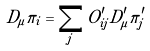<formula> <loc_0><loc_0><loc_500><loc_500>D _ { \mu } \pi _ { i } = \sum _ { j } O ^ { \prime } _ { i j } D ^ { \prime } _ { \mu } \pi ^ { \prime } _ { j }</formula> 